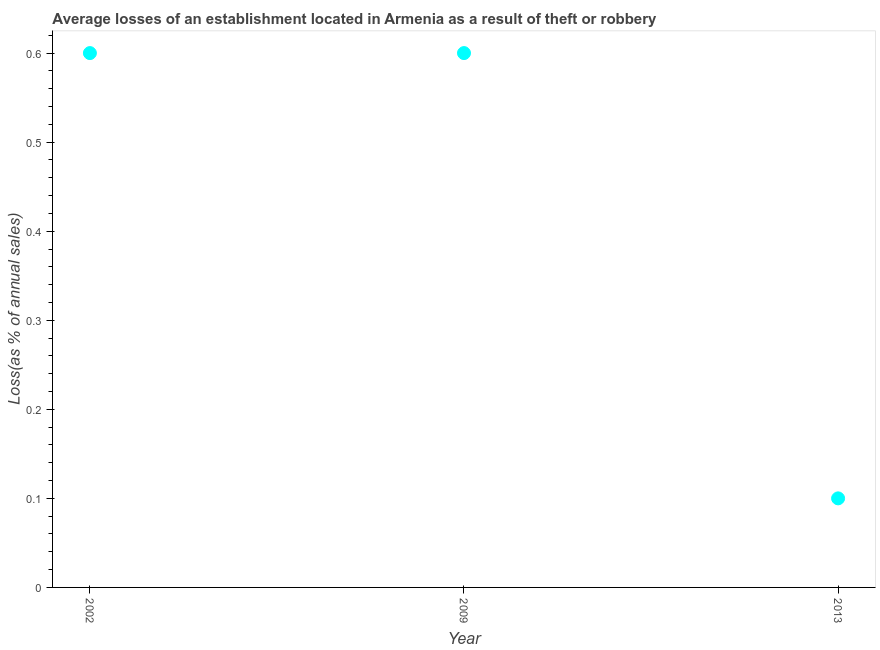Across all years, what is the maximum losses due to theft?
Your response must be concise. 0.6. Across all years, what is the minimum losses due to theft?
Ensure brevity in your answer.  0.1. In which year was the losses due to theft maximum?
Your answer should be compact. 2002. What is the average losses due to theft per year?
Your answer should be compact. 0.43. What is the median losses due to theft?
Give a very brief answer. 0.6. Is the difference between the losses due to theft in 2002 and 2013 greater than the difference between any two years?
Ensure brevity in your answer.  Yes. What is the difference between the highest and the second highest losses due to theft?
Ensure brevity in your answer.  0. How many years are there in the graph?
Your answer should be very brief. 3. What is the difference between two consecutive major ticks on the Y-axis?
Offer a terse response. 0.1. Are the values on the major ticks of Y-axis written in scientific E-notation?
Make the answer very short. No. Does the graph contain any zero values?
Your answer should be compact. No. Does the graph contain grids?
Provide a succinct answer. No. What is the title of the graph?
Your response must be concise. Average losses of an establishment located in Armenia as a result of theft or robbery. What is the label or title of the X-axis?
Your answer should be compact. Year. What is the label or title of the Y-axis?
Make the answer very short. Loss(as % of annual sales). What is the Loss(as % of annual sales) in 2009?
Give a very brief answer. 0.6. What is the difference between the Loss(as % of annual sales) in 2002 and 2009?
Your answer should be compact. 0. What is the difference between the Loss(as % of annual sales) in 2009 and 2013?
Provide a succinct answer. 0.5. What is the ratio of the Loss(as % of annual sales) in 2002 to that in 2013?
Keep it short and to the point. 6. 